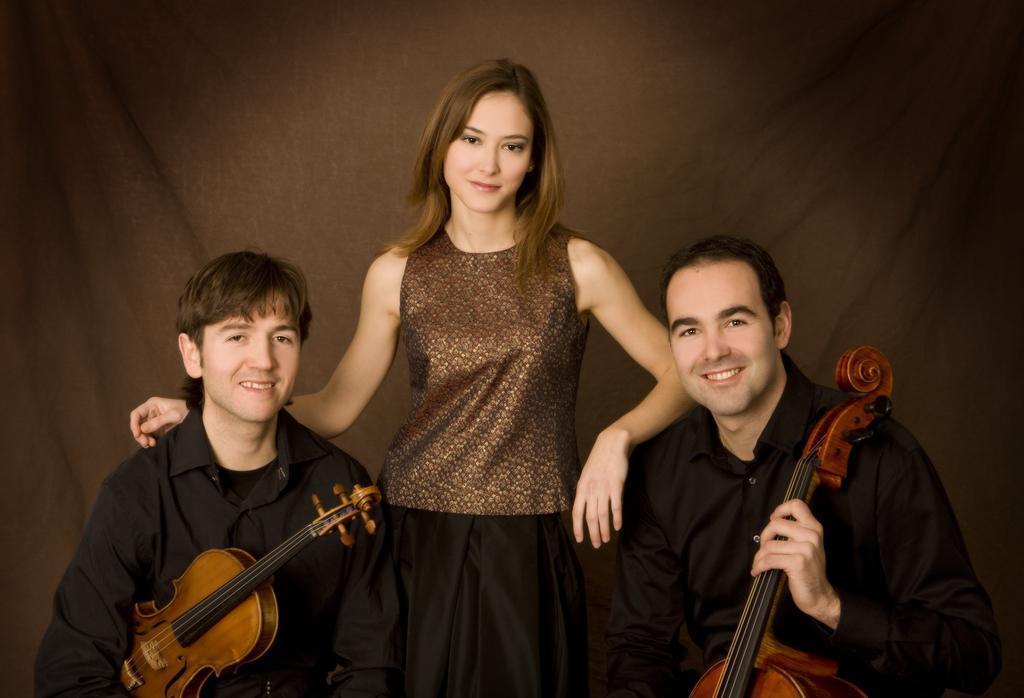In one or two sentences, can you explain what this image depicts? In this picture we can see a woman and two men in the middle. They are holding a guitar with their hands. On the background there is a cloth. 